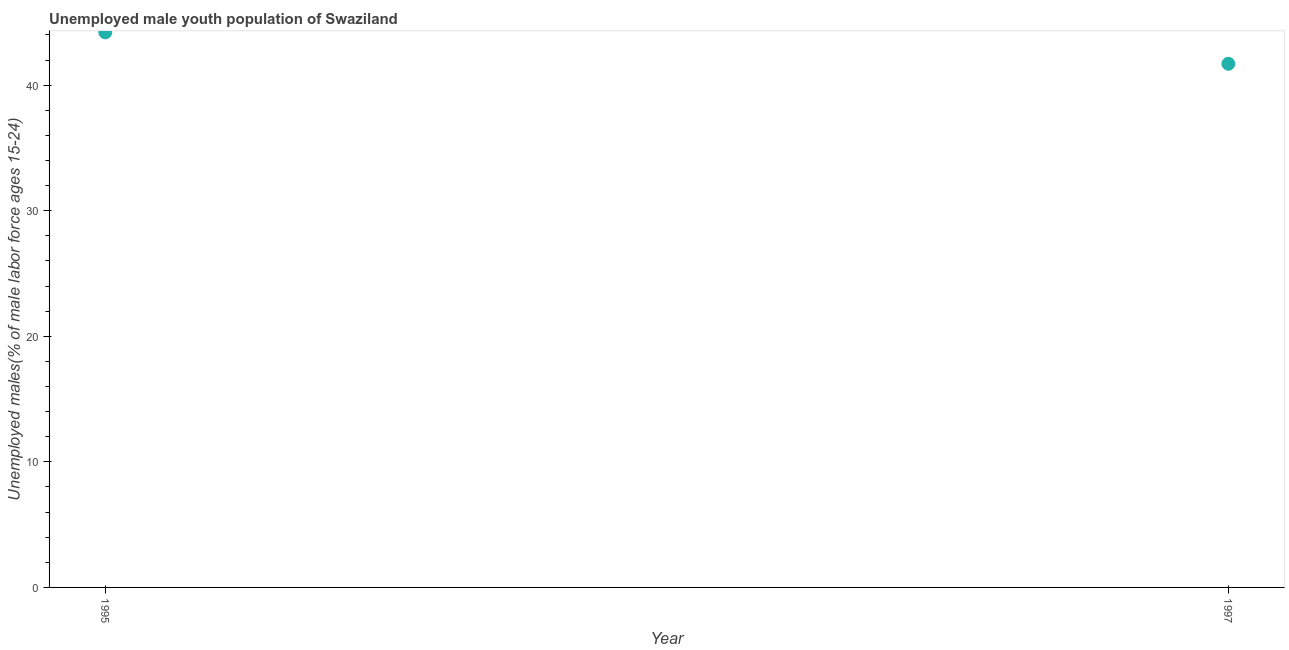What is the unemployed male youth in 1995?
Your answer should be compact. 44.2. Across all years, what is the maximum unemployed male youth?
Keep it short and to the point. 44.2. Across all years, what is the minimum unemployed male youth?
Offer a very short reply. 41.7. What is the sum of the unemployed male youth?
Ensure brevity in your answer.  85.9. What is the difference between the unemployed male youth in 1995 and 1997?
Give a very brief answer. 2.5. What is the average unemployed male youth per year?
Make the answer very short. 42.95. What is the median unemployed male youth?
Keep it short and to the point. 42.95. In how many years, is the unemployed male youth greater than 12 %?
Keep it short and to the point. 2. What is the ratio of the unemployed male youth in 1995 to that in 1997?
Keep it short and to the point. 1.06. Is the unemployed male youth in 1995 less than that in 1997?
Provide a succinct answer. No. Does the unemployed male youth monotonically increase over the years?
Offer a very short reply. No. How many years are there in the graph?
Offer a terse response. 2. What is the difference between two consecutive major ticks on the Y-axis?
Ensure brevity in your answer.  10. Are the values on the major ticks of Y-axis written in scientific E-notation?
Offer a very short reply. No. Does the graph contain grids?
Your answer should be very brief. No. What is the title of the graph?
Your response must be concise. Unemployed male youth population of Swaziland. What is the label or title of the Y-axis?
Your answer should be very brief. Unemployed males(% of male labor force ages 15-24). What is the Unemployed males(% of male labor force ages 15-24) in 1995?
Provide a succinct answer. 44.2. What is the Unemployed males(% of male labor force ages 15-24) in 1997?
Make the answer very short. 41.7. What is the difference between the Unemployed males(% of male labor force ages 15-24) in 1995 and 1997?
Offer a very short reply. 2.5. What is the ratio of the Unemployed males(% of male labor force ages 15-24) in 1995 to that in 1997?
Keep it short and to the point. 1.06. 